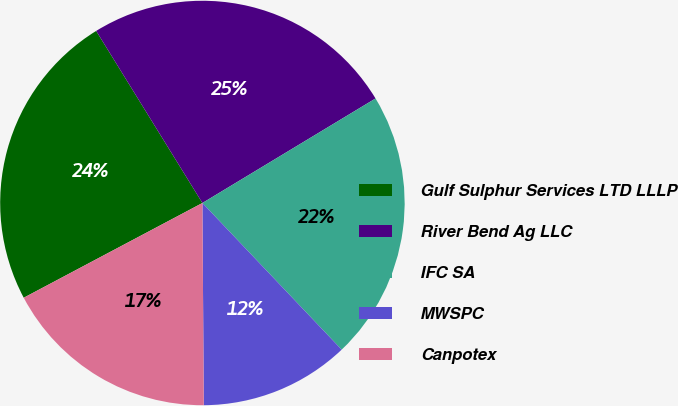Convert chart. <chart><loc_0><loc_0><loc_500><loc_500><pie_chart><fcel>Gulf Sulphur Services LTD LLLP<fcel>River Bend Ag LLC<fcel>IFC SA<fcel>MWSPC<fcel>Canpotex<nl><fcel>23.96%<fcel>25.16%<fcel>21.56%<fcel>11.98%<fcel>17.35%<nl></chart> 